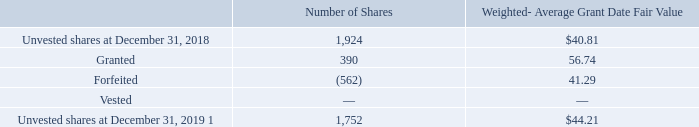Performance-Based Restricted Stock Units
PRSU activity is summarized as follows (shares in thousands):
1 Assumes maximum achievement of the specified financial targets.
The weighted-average grant date fair value of PRSUs granted during the years ended December 31, 2019, 2018, and 2017 was $56.74, $40.53, and $41.73, respectively.
Unrecognized compensation expense related to unvested PRSUs was $16.9 million at December 31, 2019, which is expected to be recognized over a weighted-average period of 1.7 years.
What was the weighted-average grant date fair value of PRSUs granted in 2017? $41.73. What was the unrecognized compensation expense related to unvested PRSUs in 2019? $16.9 million. What was the weighted-average grant date fair value of PRSUs granted in 2018? $40.53. What is the difference in weighted-average grant date fair value between granted and forfeited shares? (56.74-41.29)
Answer: 15.45. What is the sum of number of unvested shares in 2018 and number of granted shares?
Answer scale should be: thousand. (1,924+390)
Answer: 2314. What is the change in number of unvested shares between 2018 and 2019?
Answer scale should be: thousand. (1,752-1,924)
Answer: -172. 